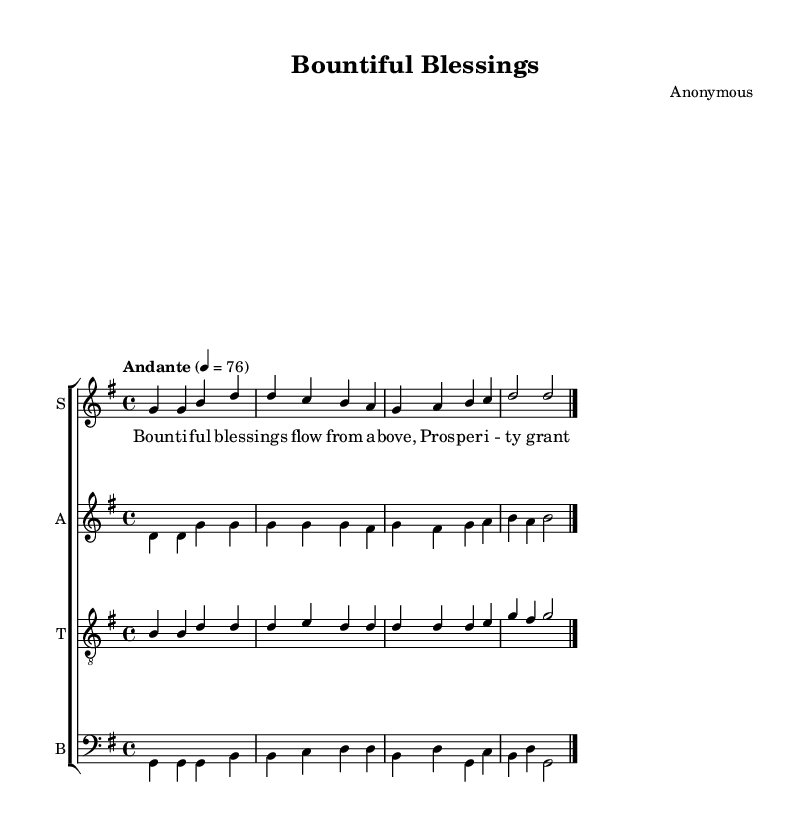What is the key signature of this music? The key signature is G major, which contains one sharp (F#). This can be determined by looking at the key signature indicated at the beginning of the score.
Answer: G major What is the time signature of this piece? The time signature is 4/4, meaning there are four beats in each measure, and the quarter note receives one beat. This is indicated at the beginning of the score after the key signature.
Answer: 4/4 What is the tempo marking for this song? The tempo marking is "Andante," which indicates a moderately slow tempo. This is specified in the score and provides guidance on the speed at which to perform the piece.
Answer: Andante How many voices are present in this choir piece? There are four voices: soprano, alto, tenor, and bass. This can be seen in the layout of the score, where each voice has its own staff labeled accordingly.
Answer: Four What is the first lyric of the piece? The first lyric is "Bountiful." This is found at the beginning of the lyrics section corresponding to the soprano part, indicating the start of the text for the music.
Answer: Bountiful Which voice has the lowest pitch? The bass voice has the lowest pitch. By examining the notations on the staves, the bass part is placed on the bass clef, which generally indicates lower pitches than the treble clefs used for soprano, alto, and tenor.
Answer: Bass What is the last note of the soprano part? The last note of the soprano part is D. This can be observed at the end of the soprano notation, where it concludes on the note D before the bar line.
Answer: D 